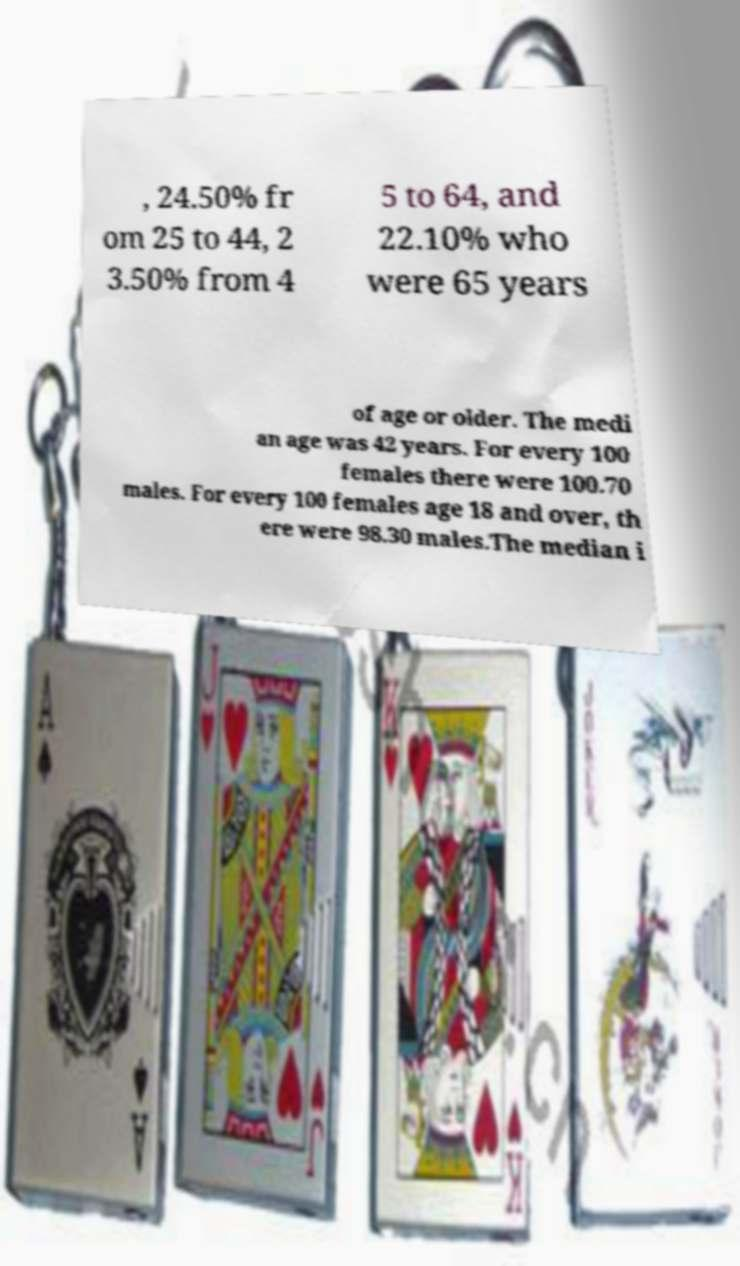There's text embedded in this image that I need extracted. Can you transcribe it verbatim? , 24.50% fr om 25 to 44, 2 3.50% from 4 5 to 64, and 22.10% who were 65 years of age or older. The medi an age was 42 years. For every 100 females there were 100.70 males. For every 100 females age 18 and over, th ere were 98.30 males.The median i 